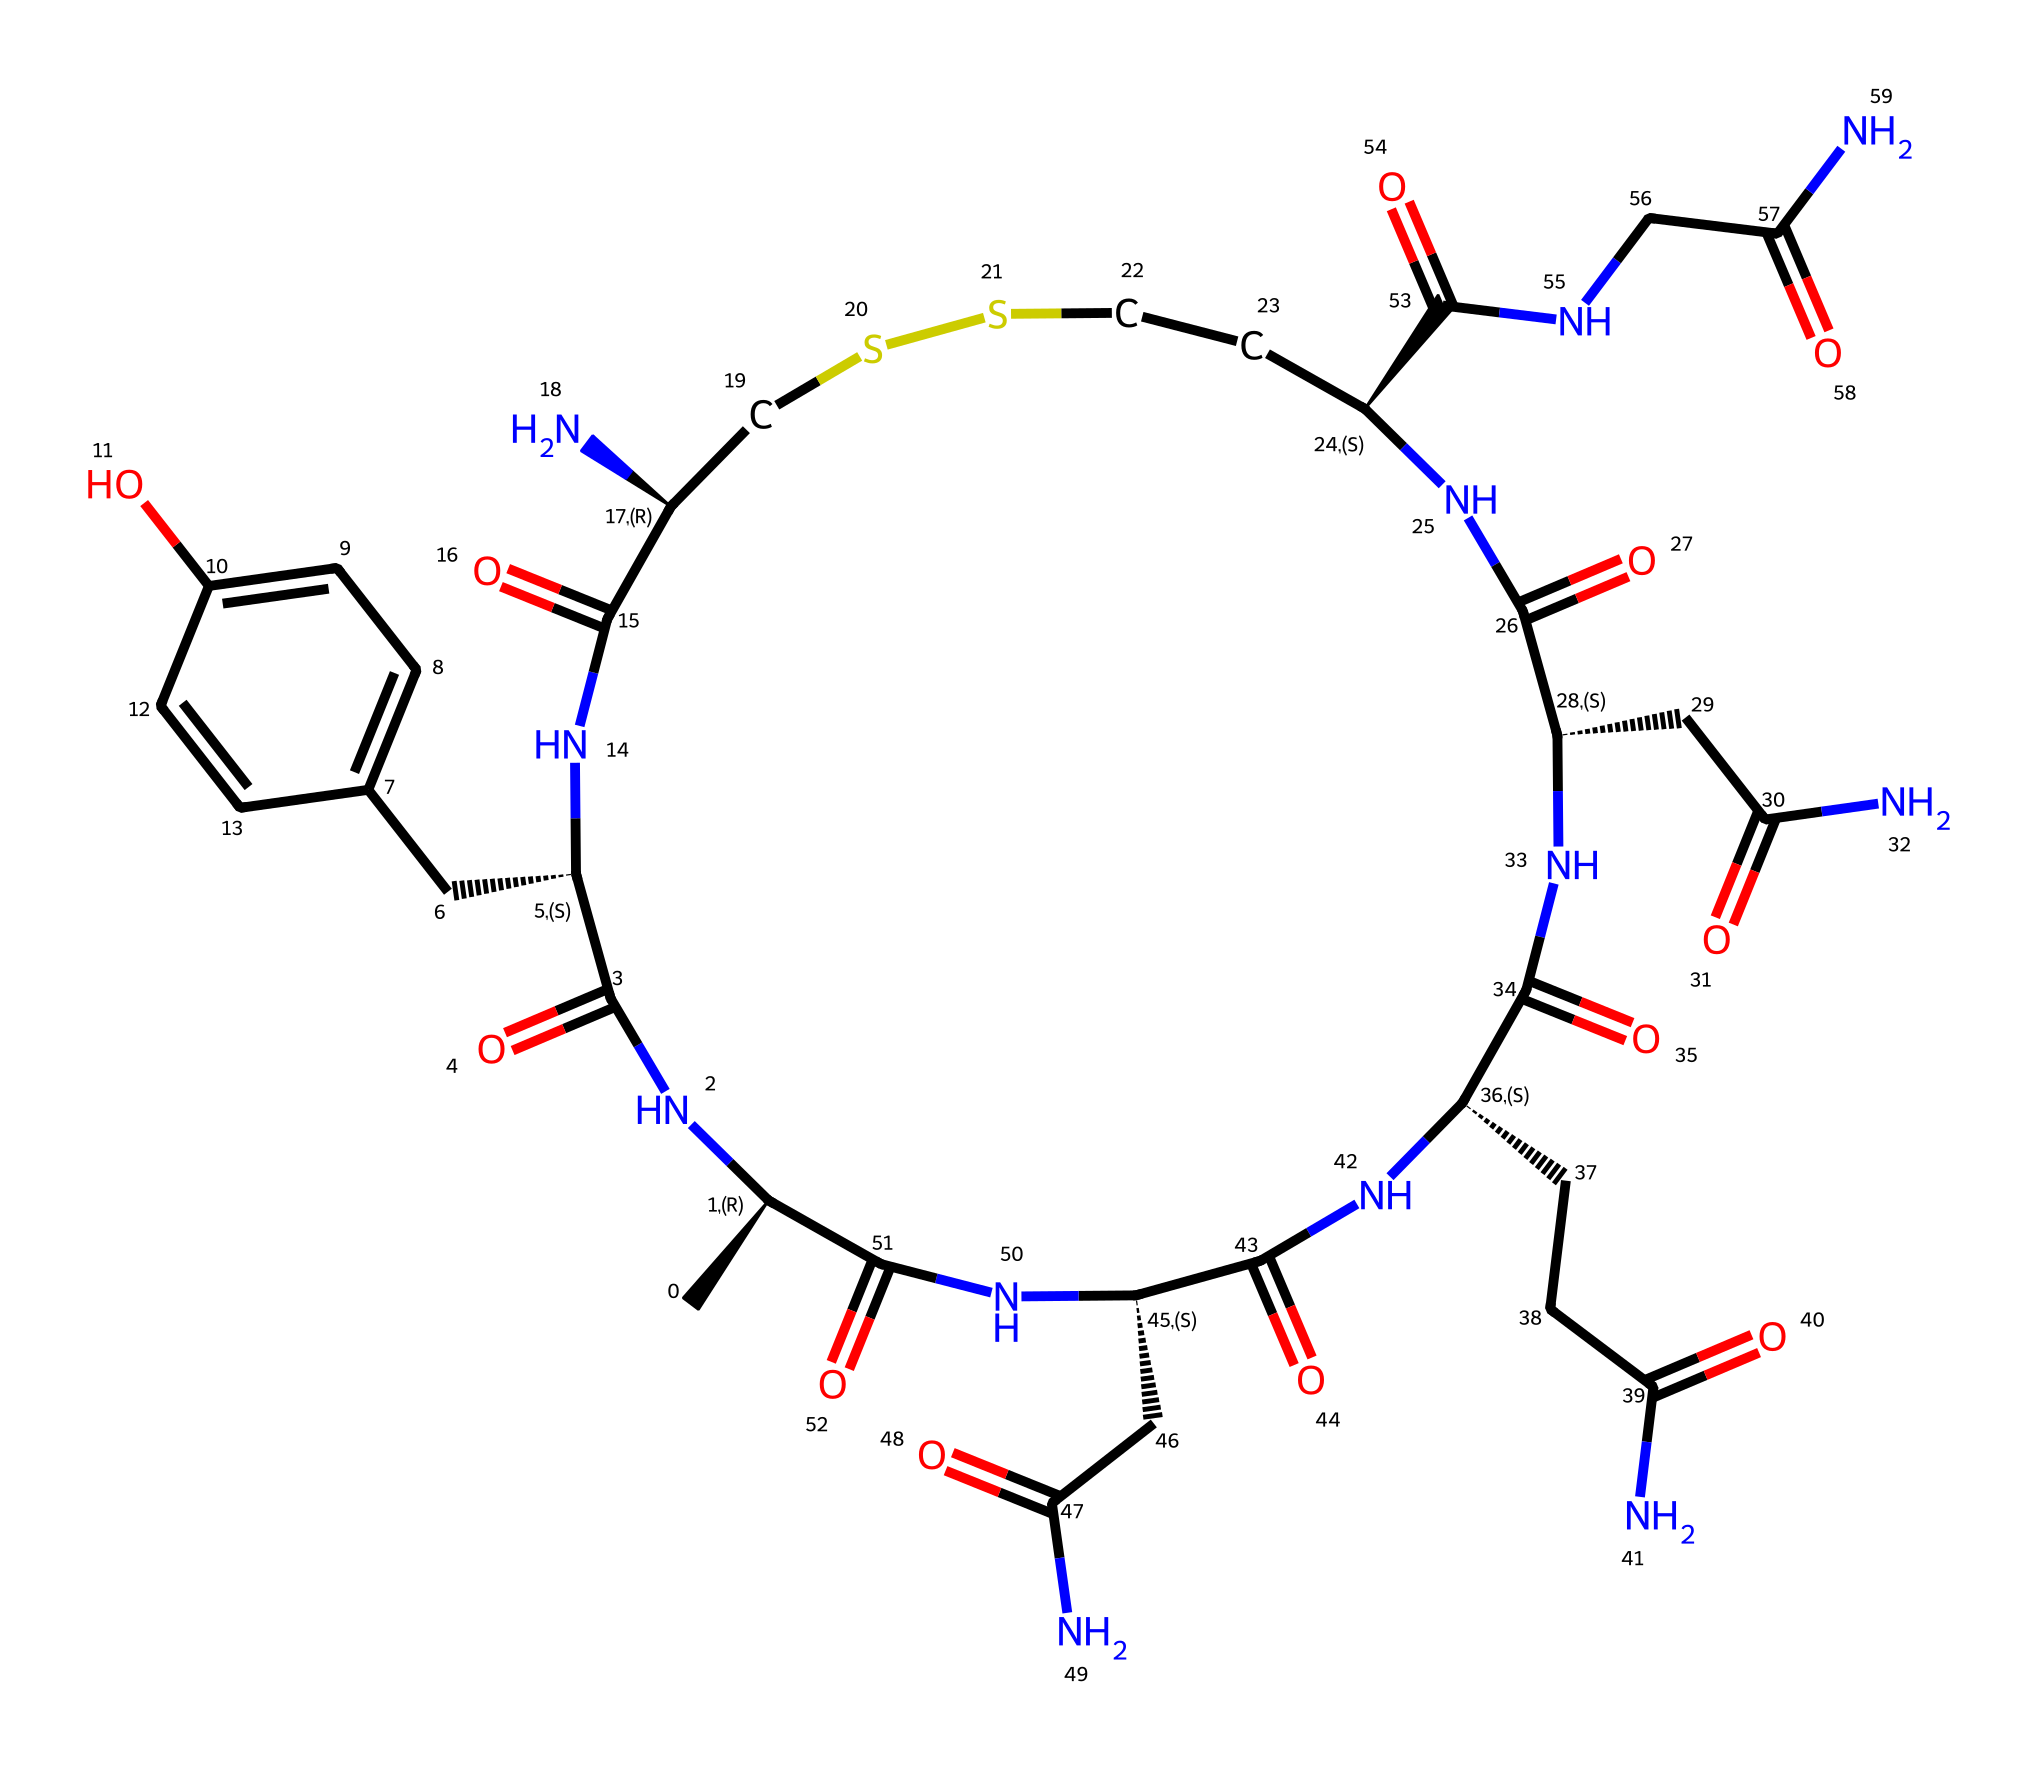What is the total number of carbon atoms in oxytocin? By examining the structural representation, we can count the carbon (C) atoms represented in the SMILES notation. Each 'C' in the SMILES stands for a carbon atom. In the given structure, there are 13 carbon atoms.
Answer: 13 How many nitrogen atoms are present in the molecule? The SMILES representation includes 'N' for nitrogen atoms. Scanning through the structure, we count a total of 6 nitrogen atoms.
Answer: 6 What functional group is primarily responsible for the peptide nature of oxytocin? The presence of amide bonds (indicated by NC(=O) and C(=O)N sequences) in the structure signifies that oxytocin is a peptide hormone. This is crucial for representing the bond between amino acids.
Answer: amide What is the molecular formula of oxytocin as indicated by the SMILES? By interpreting the chemical structure from the SMILES, we can derive the molecular formula by counting the atoms: C, H, O, and N. Consequently, the molecular formula is C43H66N12O12S2.
Answer: C43H66N12O12S2 Which part of the molecule is crucial for its role in social bonding? The oxytocin molecule contains a specific cyclic structure that includes a disulfide bridge (CSS) within its 3D conformation, which is essential for maintaining its biological function related to social bonding.
Answer: cyclic structure What is the primary biological function associated with oxytocin? Oxytocin is recognized for its significant role in promoting social bonding, trust, and emotional recognition, often influencing relationships and social behaviors, especially within teams.
Answer: social bonding Which elements are present in the oxytocin structure aside from carbon, hydrogen, nitrogen, and oxygen? The SMILES indicates the presence of sulfur (S) as another element in the oxytocin structure, important for the formation of disulfide bonds.
Answer: sulfur 